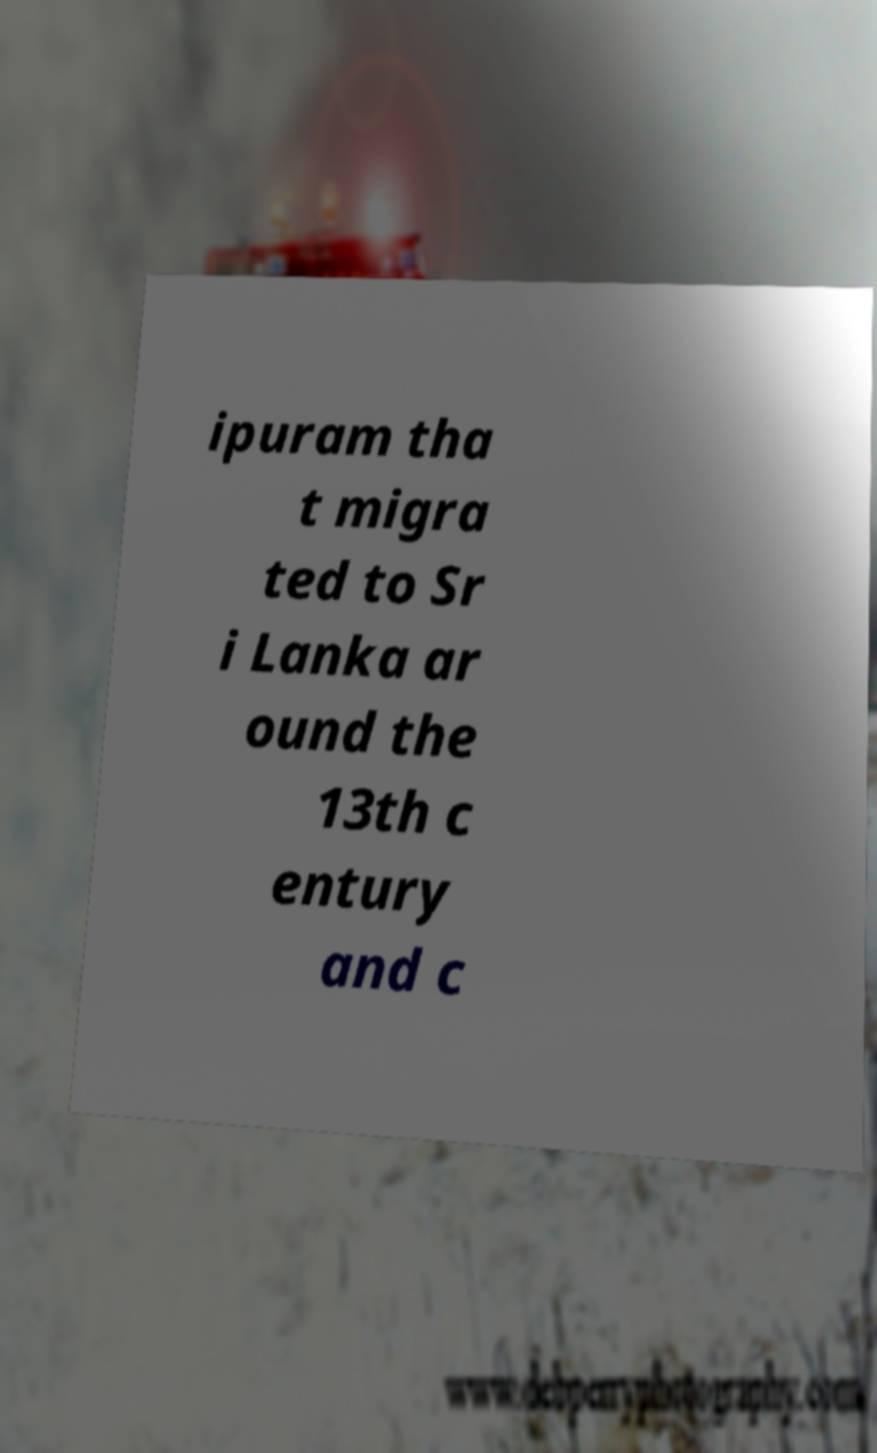Please read and relay the text visible in this image. What does it say? ipuram tha t migra ted to Sr i Lanka ar ound the 13th c entury and c 